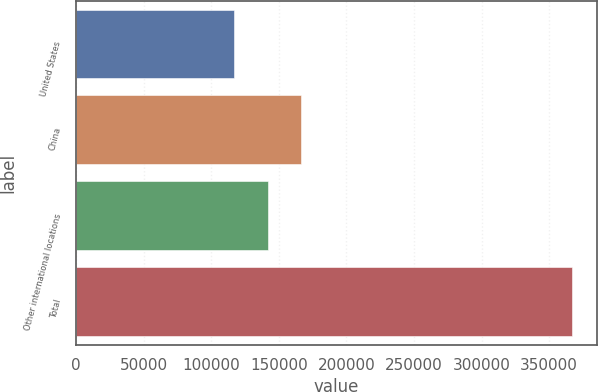Convert chart to OTSL. <chart><loc_0><loc_0><loc_500><loc_500><bar_chart><fcel>United States<fcel>China<fcel>Other international locations<fcel>Total<nl><fcel>116591<fcel>166666<fcel>141628<fcel>366966<nl></chart> 